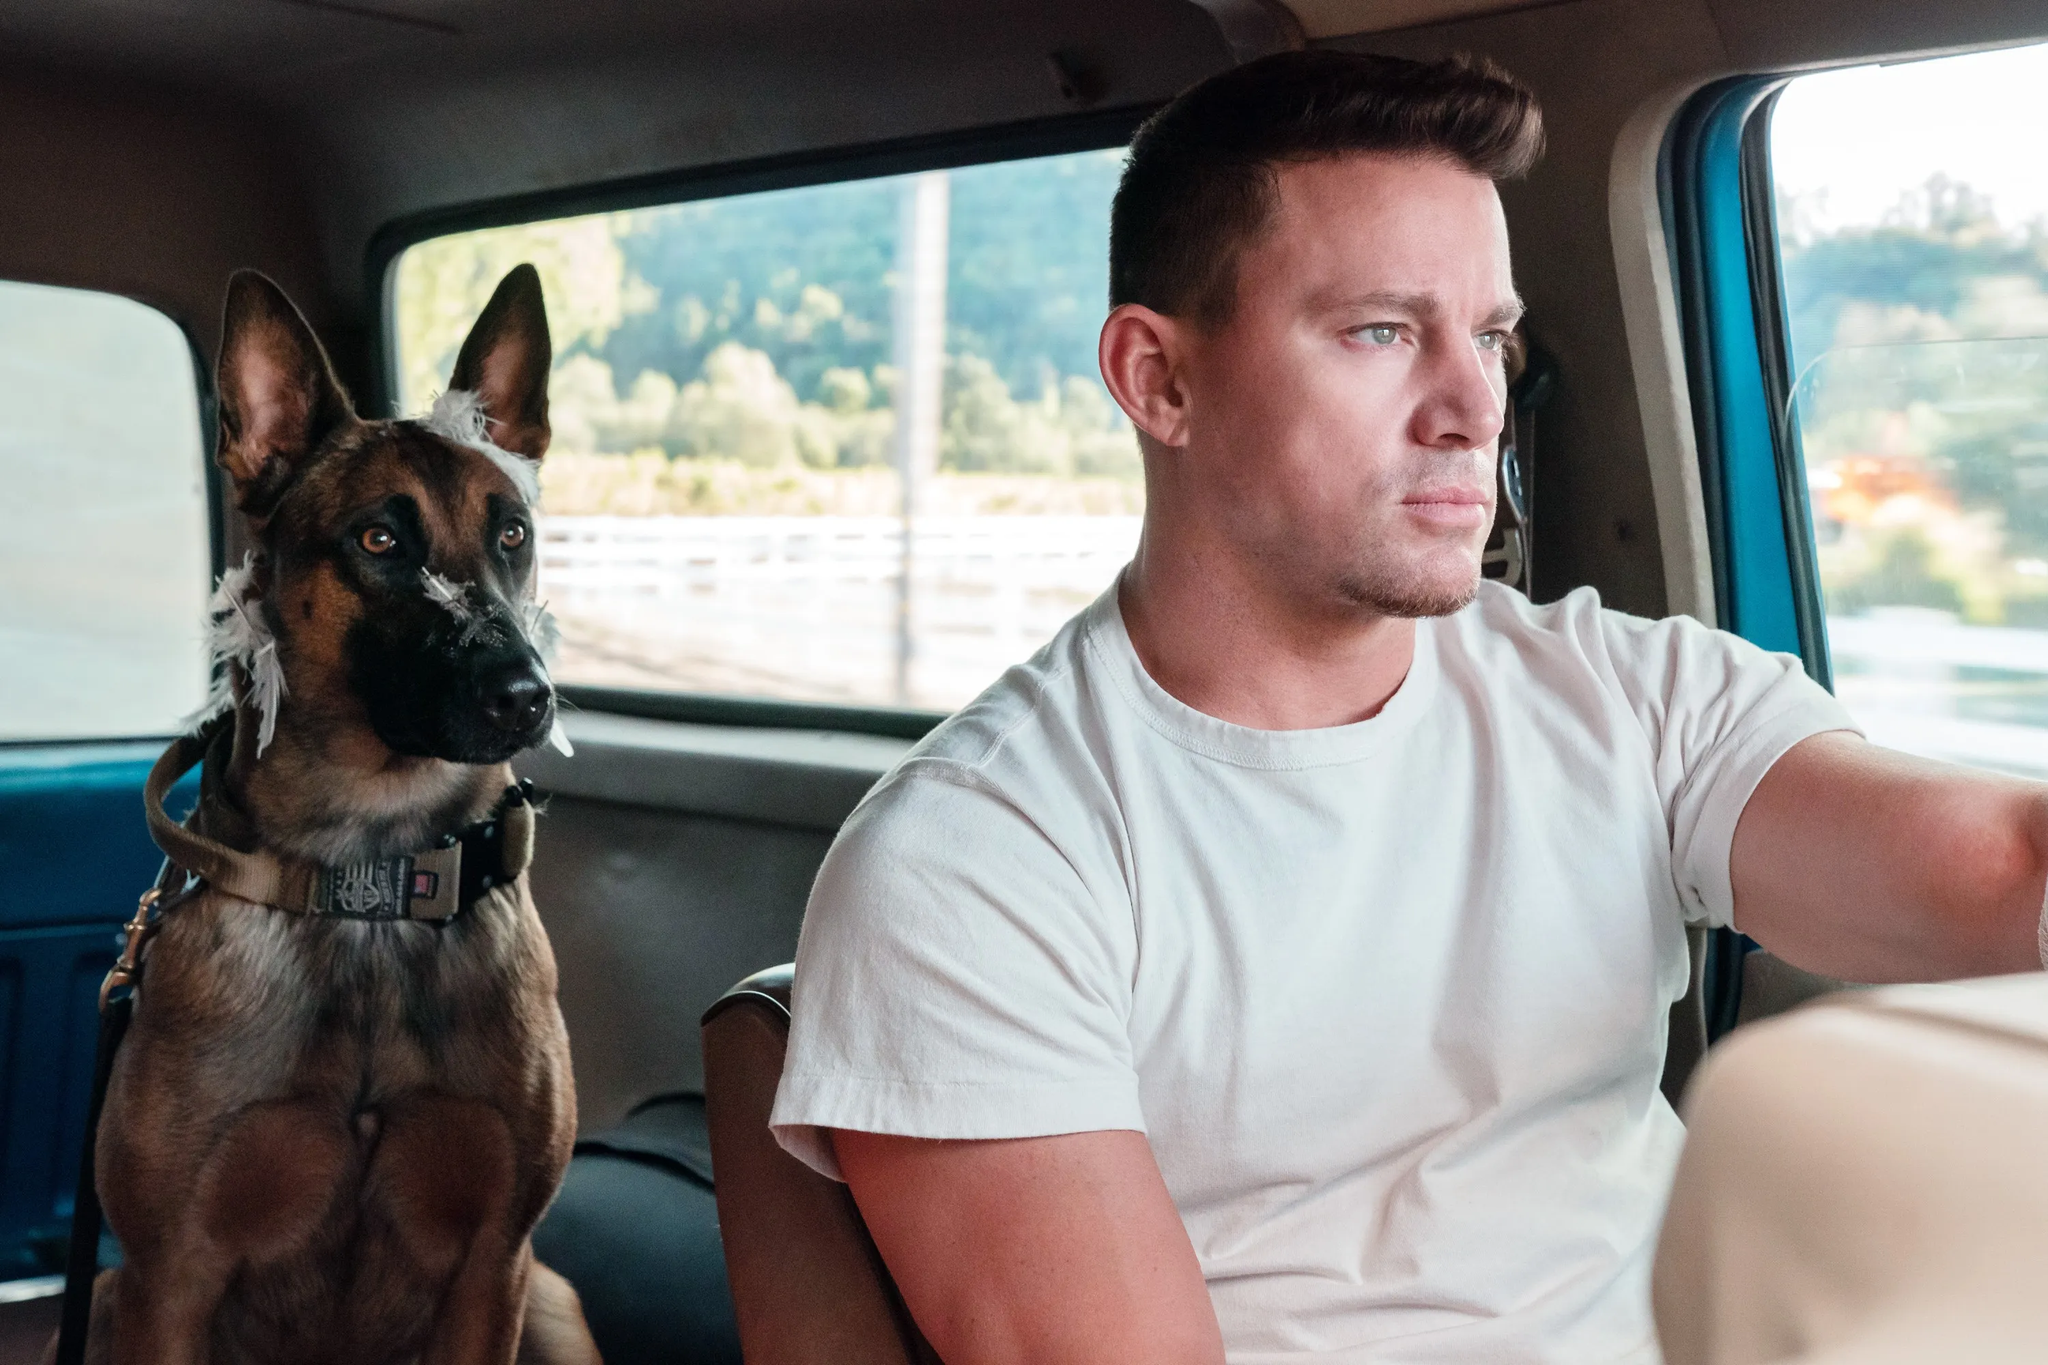What can we infer about their journey based on this image? The scene indicates that they're traveling, possibly on a road trip. The lighting and blurred background suggest it's daytime and they are moving at a moderate speed. Judging by the relaxed demeanor of both the man and the dog, the journey seems leisurely and not rushed. The open window and daylight also hint at a casual and enjoyable drive through a scenic route. 